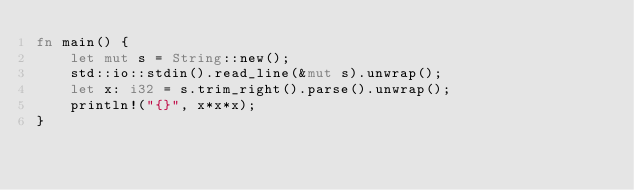Convert code to text. <code><loc_0><loc_0><loc_500><loc_500><_Rust_>fn main() {
    let mut s = String::new();
    std::io::stdin().read_line(&mut s).unwrap();
    let x: i32 = s.trim_right().parse().unwrap();
    println!("{}", x*x*x);
}

</code> 